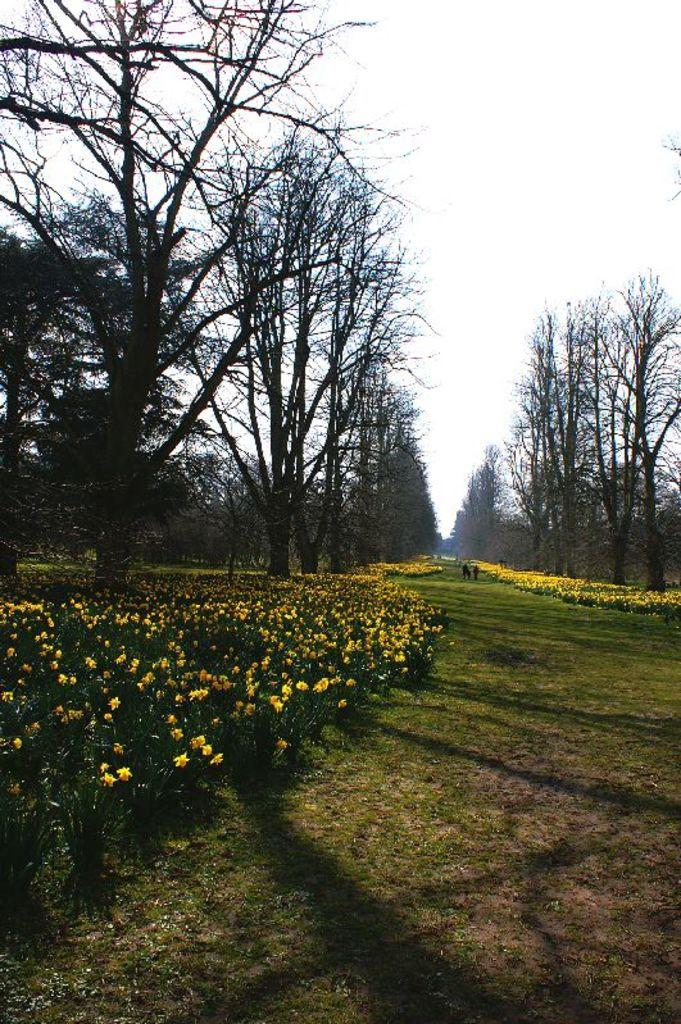What type of vegetation can be seen in the image? There are plants, flowers, and trees in the image. What type of ground cover is present in the image? There is grass in the image. What can be seen in the background of the image? The sky is visible in the background of the image. How many nails are being hammered into the boats in the image? There are no boats or nails present in the image. What type of creature is seen interacting with the flowers in the image? There is no creature interacting with the flowers in the image; only plants, flowers, trees, grass, and the sky are present. 